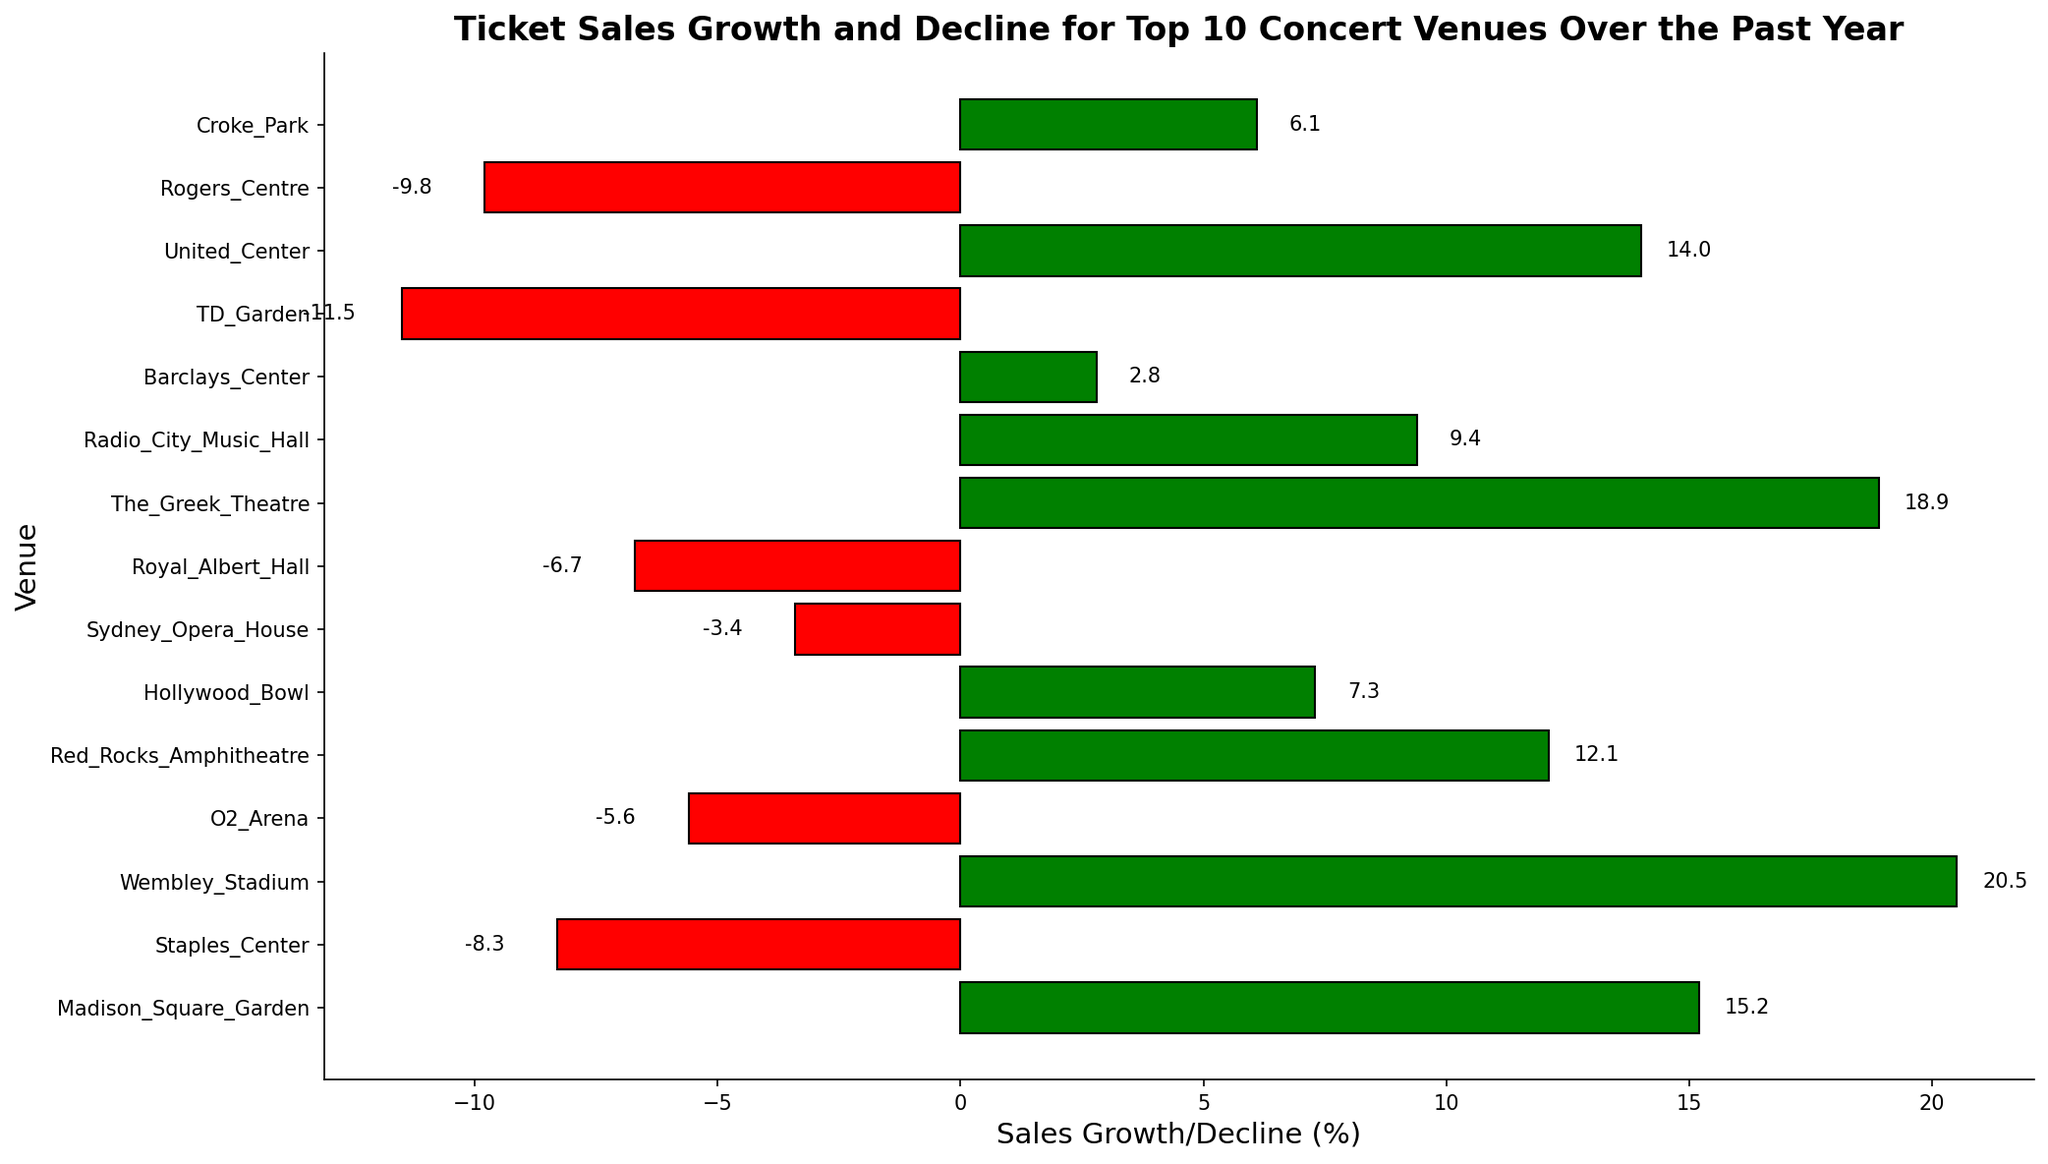What’s the overall range of sales growth and decline shown in the chart? The highest growth is 20.5% at Wembley Stadium, and the greatest decline is -11.5% at TD Garden, so the range is 20.5% - (-11.5%) = 32%.
Answer: 32% Which venue has the highest ticket sales growth? Look for the bar with the highest positive value. Wembley Stadium has the highest ticket sales growth at 20.5%.
Answer: Wembley Stadium How many venues experienced a decline in ticket sales over the past year? Count the bars colored red. There are 6 red bars corresponding to venues with negative growth.
Answer: 6 venues Which venues experienced a decline greater than 5%? Identify the red bars with negative values less than -5%. These venues are Staples Center (-8.3%), O2 Arena (-5.6%), Royal Albert Hall (-6.7%), TD Garden (-11.5%), and Rogers Centre (-9.8%).
Answer: Staples Center, O2 Arena, Royal Albert Hall, TD Garden, Rogers Centre What is the average ticket sales growth for venues with positive growth? Sum all positive growth values and divide by the count of such values. The values are 15.2, 20.5, 12.1, 7.3, 18.9, 9.4, 2.8, 14.0, 6.1. The sum is 106.3, and there are 9 values. The average is 106.3/9 ≈ 11.8.
Answer: 11.8% Compare the sales growth of Madison Square Garden and The Greek Theatre. Madison Square Garden has a growth of 15.2% and The Greek Theatre has 18.9%. So, The Greek Theatre has greater growth.
Answer: The Greek Theatre Which venue has the closest ticket sales growth to 10%? Compare values to 10%. Radio City Music Hall has a growth of 9.4%, which is closest to 10%.
Answer: Radio City Music Hall What’s the difference in ticket sales growth between United Center and Staples Center? Identify their values, United Center is at 14.0% and Staples Center at -8.3%. Difference = 14.0 - (-8.3) = 22.3%.
Answer: 22.3% How many venues have a growth rate above 10%? Count the bars with values greater than 10%. These values are 15.2, 20.5, 12.1, 18.9, and 14.0. There are 5 such bars.
Answer: 5 venues Compare the combined ticket sales decline of O2 Arena and TD Garden. Sum their decline values. O2 Arena is -5.6% and TD Garden is -11.5%. Combined decline = -5.6 + (-11.5) = -17.1%.
Answer: -17.1% 